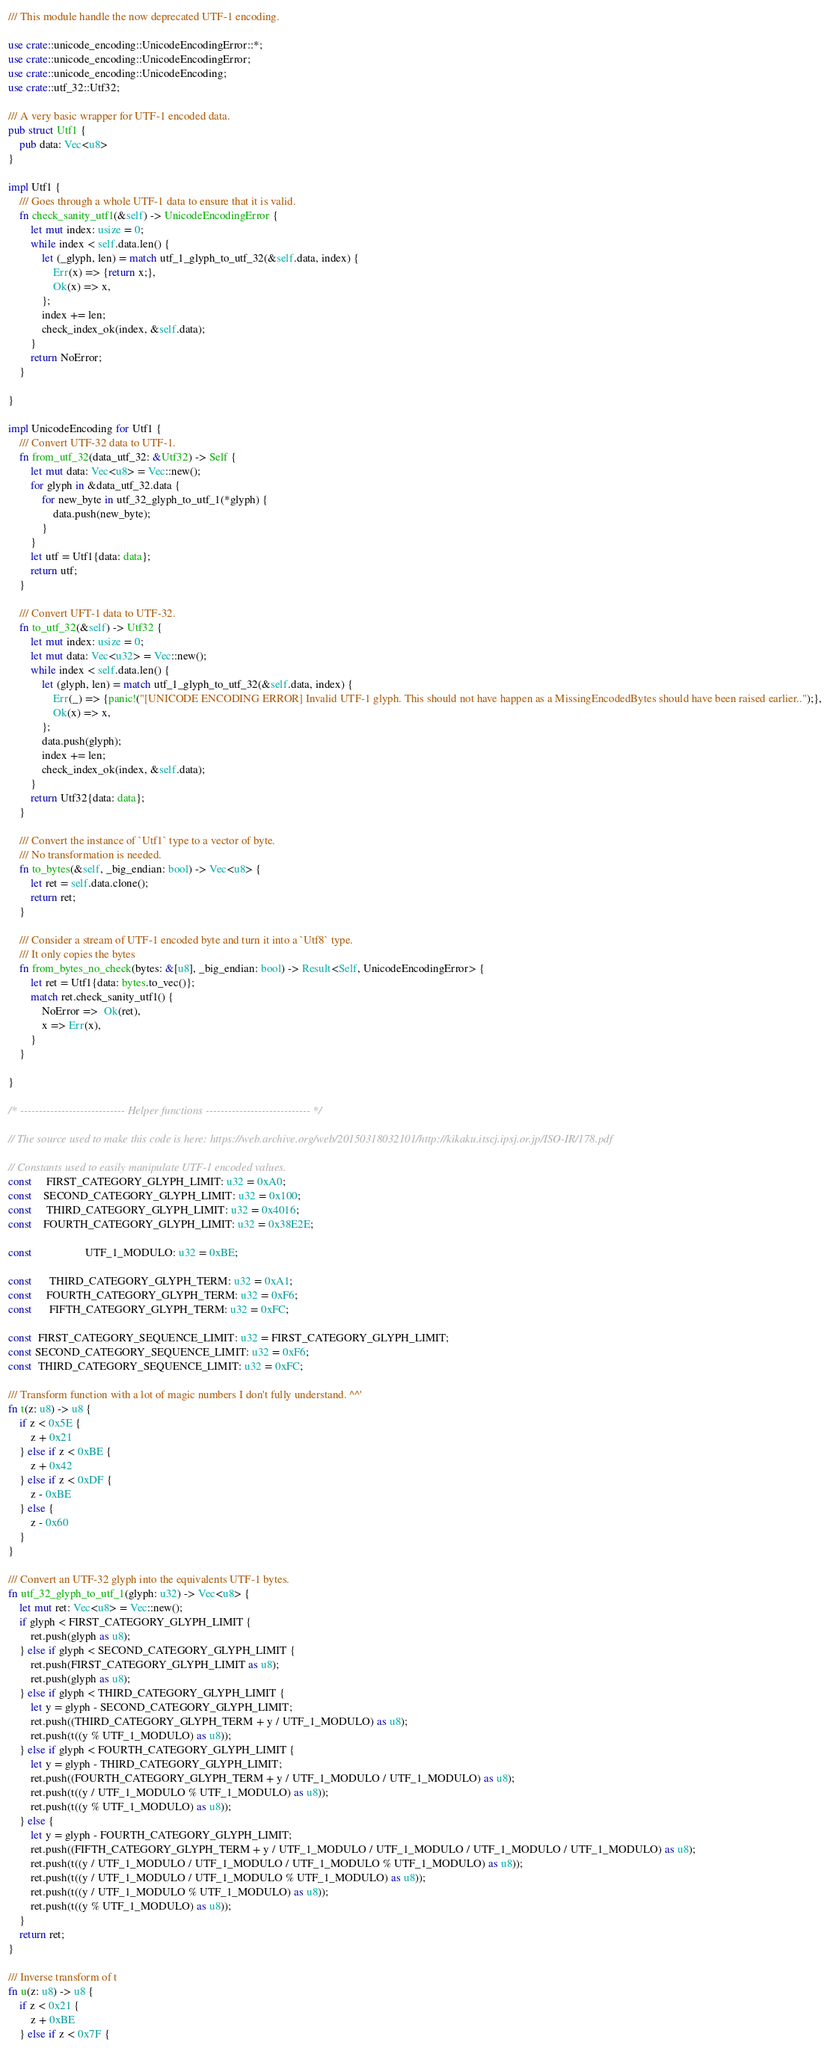<code> <loc_0><loc_0><loc_500><loc_500><_Rust_>/// This module handle the now deprecated UTF-1 encoding.

use crate::unicode_encoding::UnicodeEncodingError::*;
use crate::unicode_encoding::UnicodeEncodingError;
use crate::unicode_encoding::UnicodeEncoding;
use crate::utf_32::Utf32;

/// A very basic wrapper for UTF-1 encoded data.
pub struct Utf1 {
    pub data: Vec<u8>
}

impl Utf1 {
    /// Goes through a whole UTF-1 data to ensure that it is valid.
    fn check_sanity_utf1(&self) -> UnicodeEncodingError {
        let mut index: usize = 0;
        while index < self.data.len() {
            let (_glyph, len) = match utf_1_glyph_to_utf_32(&self.data, index) {
                Err(x) => {return x;},
                Ok(x) => x,
            };
            index += len;
            check_index_ok(index, &self.data);
        }
        return NoError;
    }

}

impl UnicodeEncoding for Utf1 {
    /// Convert UTF-32 data to UTF-1.
    fn from_utf_32(data_utf_32: &Utf32) -> Self {
        let mut data: Vec<u8> = Vec::new();
        for glyph in &data_utf_32.data {
            for new_byte in utf_32_glyph_to_utf_1(*glyph) {
                data.push(new_byte);
            }
        }
        let utf = Utf1{data: data};
        return utf;
    }

    /// Convert UFT-1 data to UTF-32.
    fn to_utf_32(&self) -> Utf32 {
        let mut index: usize = 0;
        let mut data: Vec<u32> = Vec::new();
        while index < self.data.len() {
            let (glyph, len) = match utf_1_glyph_to_utf_32(&self.data, index) {
                Err(_) => {panic!("[UNICODE ENCODING ERROR] Invalid UTF-1 glyph. This should not have happen as a MissingEncodedBytes should have been raised earlier..");},
                Ok(x) => x,
            };
            data.push(glyph);
            index += len;
            check_index_ok(index, &self.data);
        }
        return Utf32{data: data};
    }

    /// Convert the instance of `Utf1` type to a vector of byte.
    /// No transformation is needed.
    fn to_bytes(&self, _big_endian: bool) -> Vec<u8> {
        let ret = self.data.clone();
        return ret;
    }

    /// Consider a stream of UTF-1 encoded byte and turn it into a `Utf8` type.
    /// It only copies the bytes
    fn from_bytes_no_check(bytes: &[u8], _big_endian: bool) -> Result<Self, UnicodeEncodingError> {
        let ret = Utf1{data: bytes.to_vec()};
        match ret.check_sanity_utf1() {
            NoError =>  Ok(ret),
            x => Err(x),
        }
    }
    
}

/* ---------------------------- Helper functions ---------------------------- */

// The source used to make this code is here: https://web.archive.org/web/20150318032101/http://kikaku.itscj.ipsj.or.jp/ISO-IR/178.pdf

// Constants used to easily manipulate UTF-1 encoded values.
const     FIRST_CATEGORY_GLYPH_LIMIT: u32 = 0xA0;
const    SECOND_CATEGORY_GLYPH_LIMIT: u32 = 0x100;
const     THIRD_CATEGORY_GLYPH_LIMIT: u32 = 0x4016;
const    FOURTH_CATEGORY_GLYPH_LIMIT: u32 = 0x38E2E;

const                   UTF_1_MODULO: u32 = 0xBE;

const      THIRD_CATEGORY_GLYPH_TERM: u32 = 0xA1;
const     FOURTH_CATEGORY_GLYPH_TERM: u32 = 0xF6;
const      FIFTH_CATEGORY_GLYPH_TERM: u32 = 0xFC;

const  FIRST_CATEGORY_SEQUENCE_LIMIT: u32 = FIRST_CATEGORY_GLYPH_LIMIT;
const SECOND_CATEGORY_SEQUENCE_LIMIT: u32 = 0xF6;
const  THIRD_CATEGORY_SEQUENCE_LIMIT: u32 = 0xFC;

/// Transform function with a lot of magic numbers I don't fully understand. ^^'
fn t(z: u8) -> u8 {
    if z < 0x5E {
        z + 0x21
    } else if z < 0xBE {
        z + 0x42
    } else if z < 0xDF {
        z - 0xBE
    } else {
        z - 0x60
    }
}

/// Convert an UTF-32 glyph into the equivalents UTF-1 bytes.
fn utf_32_glyph_to_utf_1(glyph: u32) -> Vec<u8> {
    let mut ret: Vec<u8> = Vec::new();
    if glyph < FIRST_CATEGORY_GLYPH_LIMIT {
        ret.push(glyph as u8);
    } else if glyph < SECOND_CATEGORY_GLYPH_LIMIT {
        ret.push(FIRST_CATEGORY_GLYPH_LIMIT as u8);
        ret.push(glyph as u8);
    } else if glyph < THIRD_CATEGORY_GLYPH_LIMIT {
        let y = glyph - SECOND_CATEGORY_GLYPH_LIMIT;
        ret.push((THIRD_CATEGORY_GLYPH_TERM + y / UTF_1_MODULO) as u8);
        ret.push(t((y % UTF_1_MODULO) as u8));
    } else if glyph < FOURTH_CATEGORY_GLYPH_LIMIT {
        let y = glyph - THIRD_CATEGORY_GLYPH_LIMIT;
        ret.push((FOURTH_CATEGORY_GLYPH_TERM + y / UTF_1_MODULO / UTF_1_MODULO) as u8);
        ret.push(t((y / UTF_1_MODULO % UTF_1_MODULO) as u8));
        ret.push(t((y % UTF_1_MODULO) as u8));
    } else {
        let y = glyph - FOURTH_CATEGORY_GLYPH_LIMIT;
        ret.push((FIFTH_CATEGORY_GLYPH_TERM + y / UTF_1_MODULO / UTF_1_MODULO / UTF_1_MODULO / UTF_1_MODULO) as u8);
        ret.push(t((y / UTF_1_MODULO / UTF_1_MODULO / UTF_1_MODULO % UTF_1_MODULO) as u8));
        ret.push(t((y / UTF_1_MODULO / UTF_1_MODULO % UTF_1_MODULO) as u8));
        ret.push(t((y / UTF_1_MODULO % UTF_1_MODULO) as u8));
        ret.push(t((y % UTF_1_MODULO) as u8));
    }
    return ret;
}

/// Inverse transform of t
fn u(z: u8) -> u8 {
    if z < 0x21 {
        z + 0xBE
    } else if z < 0x7F {</code> 